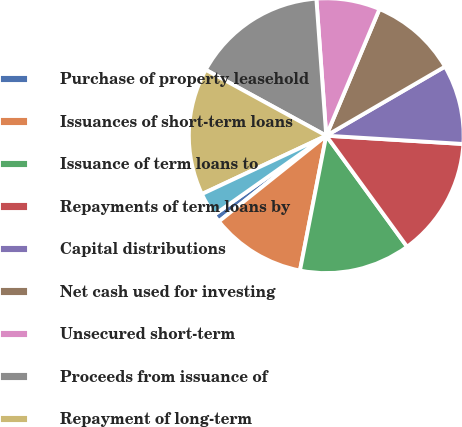<chart> <loc_0><loc_0><loc_500><loc_500><pie_chart><fcel>Purchase of property leasehold<fcel>Issuances of short-term loans<fcel>Issuance of term loans to<fcel>Repayments of term loans by<fcel>Capital distributions<fcel>Net cash used for investing<fcel>Unsecured short-term<fcel>Proceeds from issuance of<fcel>Repayment of long-term<fcel>Purchase of APEX trust<nl><fcel>0.94%<fcel>11.21%<fcel>13.08%<fcel>14.02%<fcel>9.35%<fcel>10.28%<fcel>7.48%<fcel>15.89%<fcel>14.95%<fcel>2.8%<nl></chart> 